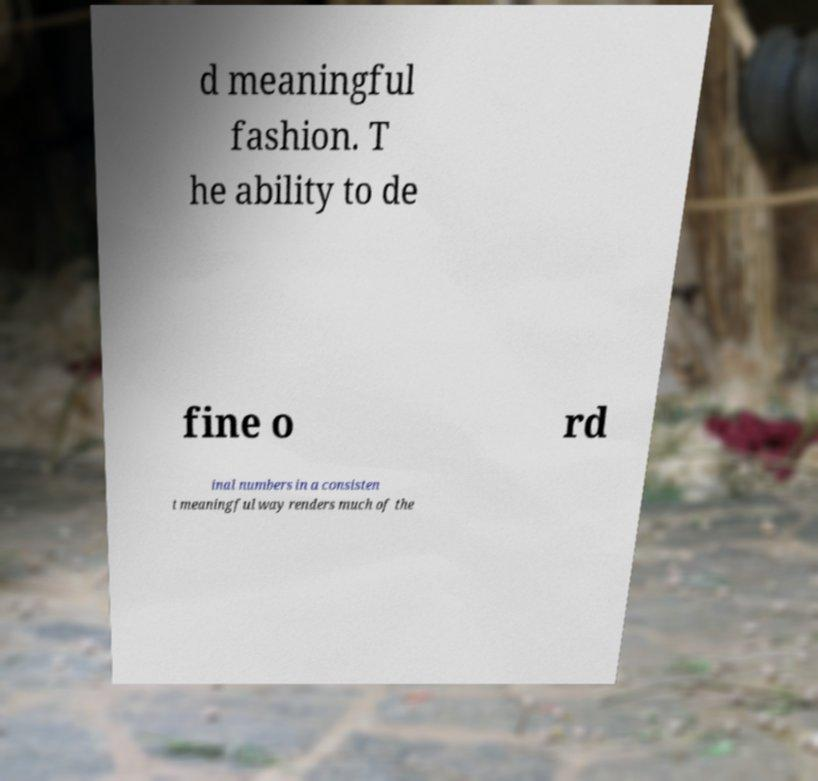There's text embedded in this image that I need extracted. Can you transcribe it verbatim? d meaningful fashion. T he ability to de fine o rd inal numbers in a consisten t meaningful way renders much of the 